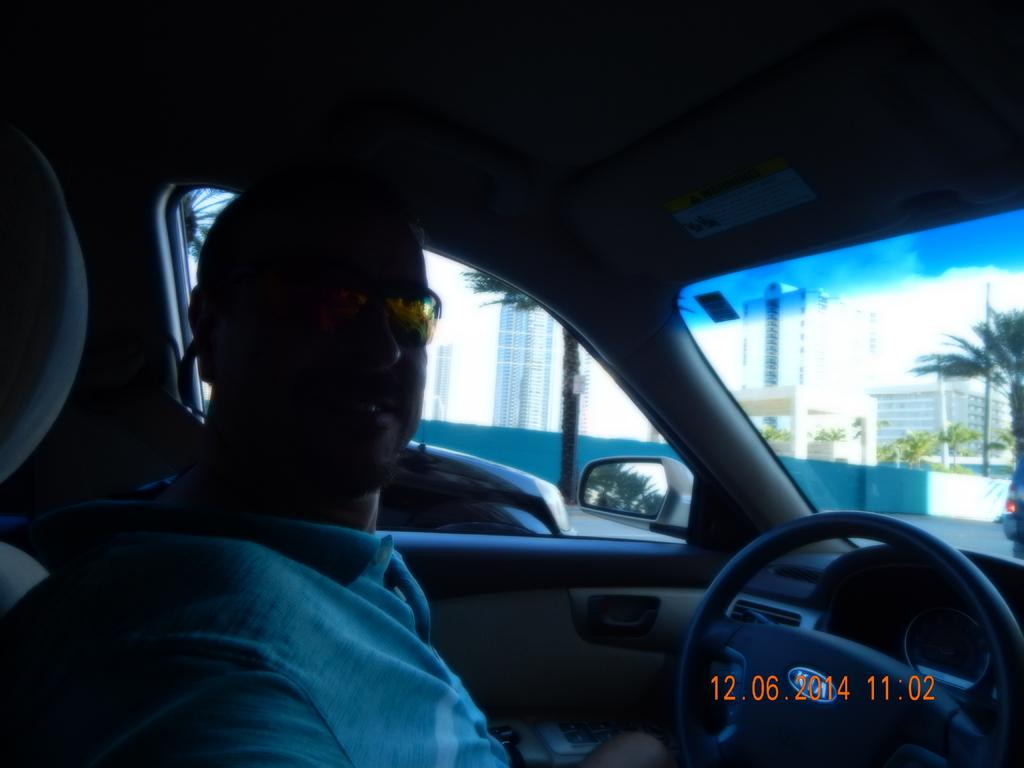Who is present in the image? There is a man in the image. What is the man doing in the image? The man is sitting on a car. What can be seen on the left side of the image? There are buildings on the left side of the image. What is in front of the man in the image? There are buildings in the front of the image. Where is the car located in the image? The car appears to be on a road. What type of cushion is the man using to sit on the car? There is no cushion mentioned or visible in the image; the man is sitting directly on the car. How many people are in the crowd surrounding the car in the image? There is no crowd present in the image; it only shows the man sitting on the car and the surrounding buildings. 